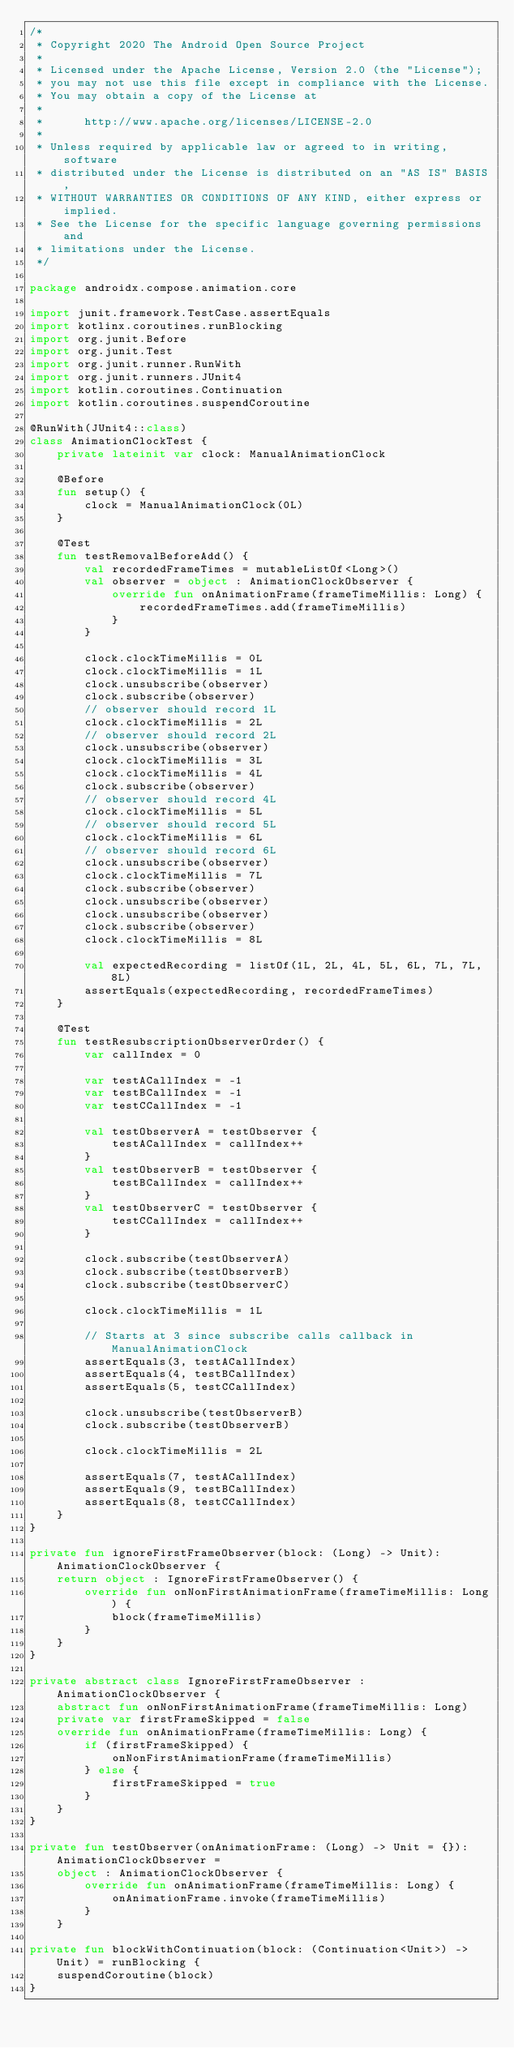Convert code to text. <code><loc_0><loc_0><loc_500><loc_500><_Kotlin_>/*
 * Copyright 2020 The Android Open Source Project
 *
 * Licensed under the Apache License, Version 2.0 (the "License");
 * you may not use this file except in compliance with the License.
 * You may obtain a copy of the License at
 *
 *      http://www.apache.org/licenses/LICENSE-2.0
 *
 * Unless required by applicable law or agreed to in writing, software
 * distributed under the License is distributed on an "AS IS" BASIS,
 * WITHOUT WARRANTIES OR CONDITIONS OF ANY KIND, either express or implied.
 * See the License for the specific language governing permissions and
 * limitations under the License.
 */

package androidx.compose.animation.core

import junit.framework.TestCase.assertEquals
import kotlinx.coroutines.runBlocking
import org.junit.Before
import org.junit.Test
import org.junit.runner.RunWith
import org.junit.runners.JUnit4
import kotlin.coroutines.Continuation
import kotlin.coroutines.suspendCoroutine

@RunWith(JUnit4::class)
class AnimationClockTest {
    private lateinit var clock: ManualAnimationClock

    @Before
    fun setup() {
        clock = ManualAnimationClock(0L)
    }

    @Test
    fun testRemovalBeforeAdd() {
        val recordedFrameTimes = mutableListOf<Long>()
        val observer = object : AnimationClockObserver {
            override fun onAnimationFrame(frameTimeMillis: Long) {
                recordedFrameTimes.add(frameTimeMillis)
            }
        }

        clock.clockTimeMillis = 0L
        clock.clockTimeMillis = 1L
        clock.unsubscribe(observer)
        clock.subscribe(observer)
        // observer should record 1L
        clock.clockTimeMillis = 2L
        // observer should record 2L
        clock.unsubscribe(observer)
        clock.clockTimeMillis = 3L
        clock.clockTimeMillis = 4L
        clock.subscribe(observer)
        // observer should record 4L
        clock.clockTimeMillis = 5L
        // observer should record 5L
        clock.clockTimeMillis = 6L
        // observer should record 6L
        clock.unsubscribe(observer)
        clock.clockTimeMillis = 7L
        clock.subscribe(observer)
        clock.unsubscribe(observer)
        clock.unsubscribe(observer)
        clock.subscribe(observer)
        clock.clockTimeMillis = 8L

        val expectedRecording = listOf(1L, 2L, 4L, 5L, 6L, 7L, 7L, 8L)
        assertEquals(expectedRecording, recordedFrameTimes)
    }

    @Test
    fun testResubscriptionObserverOrder() {
        var callIndex = 0

        var testACallIndex = -1
        var testBCallIndex = -1
        var testCCallIndex = -1

        val testObserverA = testObserver {
            testACallIndex = callIndex++
        }
        val testObserverB = testObserver {
            testBCallIndex = callIndex++
        }
        val testObserverC = testObserver {
            testCCallIndex = callIndex++
        }

        clock.subscribe(testObserverA)
        clock.subscribe(testObserverB)
        clock.subscribe(testObserverC)

        clock.clockTimeMillis = 1L

        // Starts at 3 since subscribe calls callback in ManualAnimationClock
        assertEquals(3, testACallIndex)
        assertEquals(4, testBCallIndex)
        assertEquals(5, testCCallIndex)

        clock.unsubscribe(testObserverB)
        clock.subscribe(testObserverB)

        clock.clockTimeMillis = 2L

        assertEquals(7, testACallIndex)
        assertEquals(9, testBCallIndex)
        assertEquals(8, testCCallIndex)
    }
}

private fun ignoreFirstFrameObserver(block: (Long) -> Unit): AnimationClockObserver {
    return object : IgnoreFirstFrameObserver() {
        override fun onNonFirstAnimationFrame(frameTimeMillis: Long) {
            block(frameTimeMillis)
        }
    }
}

private abstract class IgnoreFirstFrameObserver : AnimationClockObserver {
    abstract fun onNonFirstAnimationFrame(frameTimeMillis: Long)
    private var firstFrameSkipped = false
    override fun onAnimationFrame(frameTimeMillis: Long) {
        if (firstFrameSkipped) {
            onNonFirstAnimationFrame(frameTimeMillis)
        } else {
            firstFrameSkipped = true
        }
    }
}

private fun testObserver(onAnimationFrame: (Long) -> Unit = {}): AnimationClockObserver =
    object : AnimationClockObserver {
        override fun onAnimationFrame(frameTimeMillis: Long) {
            onAnimationFrame.invoke(frameTimeMillis)
        }
    }

private fun blockWithContinuation(block: (Continuation<Unit>) -> Unit) = runBlocking {
    suspendCoroutine(block)
}</code> 